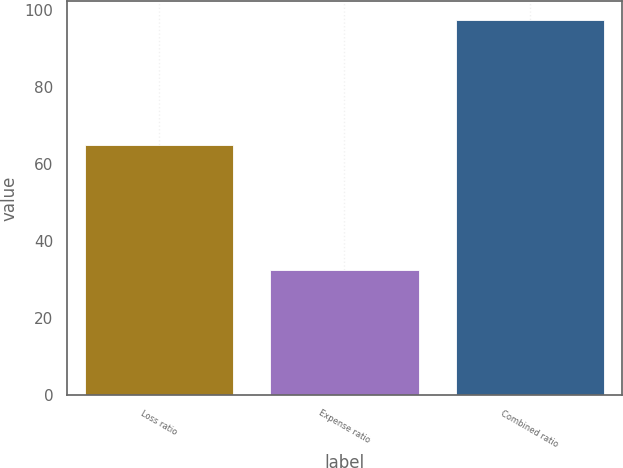<chart> <loc_0><loc_0><loc_500><loc_500><bar_chart><fcel>Loss ratio<fcel>Expense ratio<fcel>Combined ratio<nl><fcel>64.9<fcel>32.6<fcel>97.5<nl></chart> 